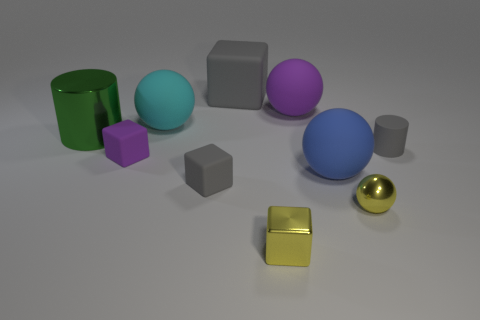What number of other objects are the same shape as the large cyan thing?
Offer a terse response. 3. Is the shape of the yellow thing right of the big blue matte thing the same as the small matte thing left of the large cyan matte object?
Give a very brief answer. No. Is the number of cylinders that are in front of the small yellow metallic ball the same as the number of big green metallic cylinders behind the big purple rubber sphere?
Provide a short and direct response. Yes. What is the shape of the purple matte object that is in front of the shiny object behind the tiny yellow object that is to the right of the blue ball?
Ensure brevity in your answer.  Cube. Does the cylinder to the right of the green cylinder have the same material as the big thing that is to the right of the purple matte sphere?
Make the answer very short. Yes. What is the shape of the gray matte object that is behind the large shiny cylinder?
Your answer should be compact. Cube. Are there fewer large balls than large brown matte balls?
Give a very brief answer. No. Is there a yellow shiny sphere that is left of the ball in front of the large blue rubber ball that is in front of the large gray rubber object?
Provide a short and direct response. No. What number of matte objects are either large gray objects or tiny green cylinders?
Offer a terse response. 1. Is the color of the big cube the same as the large metal cylinder?
Keep it short and to the point. No. 